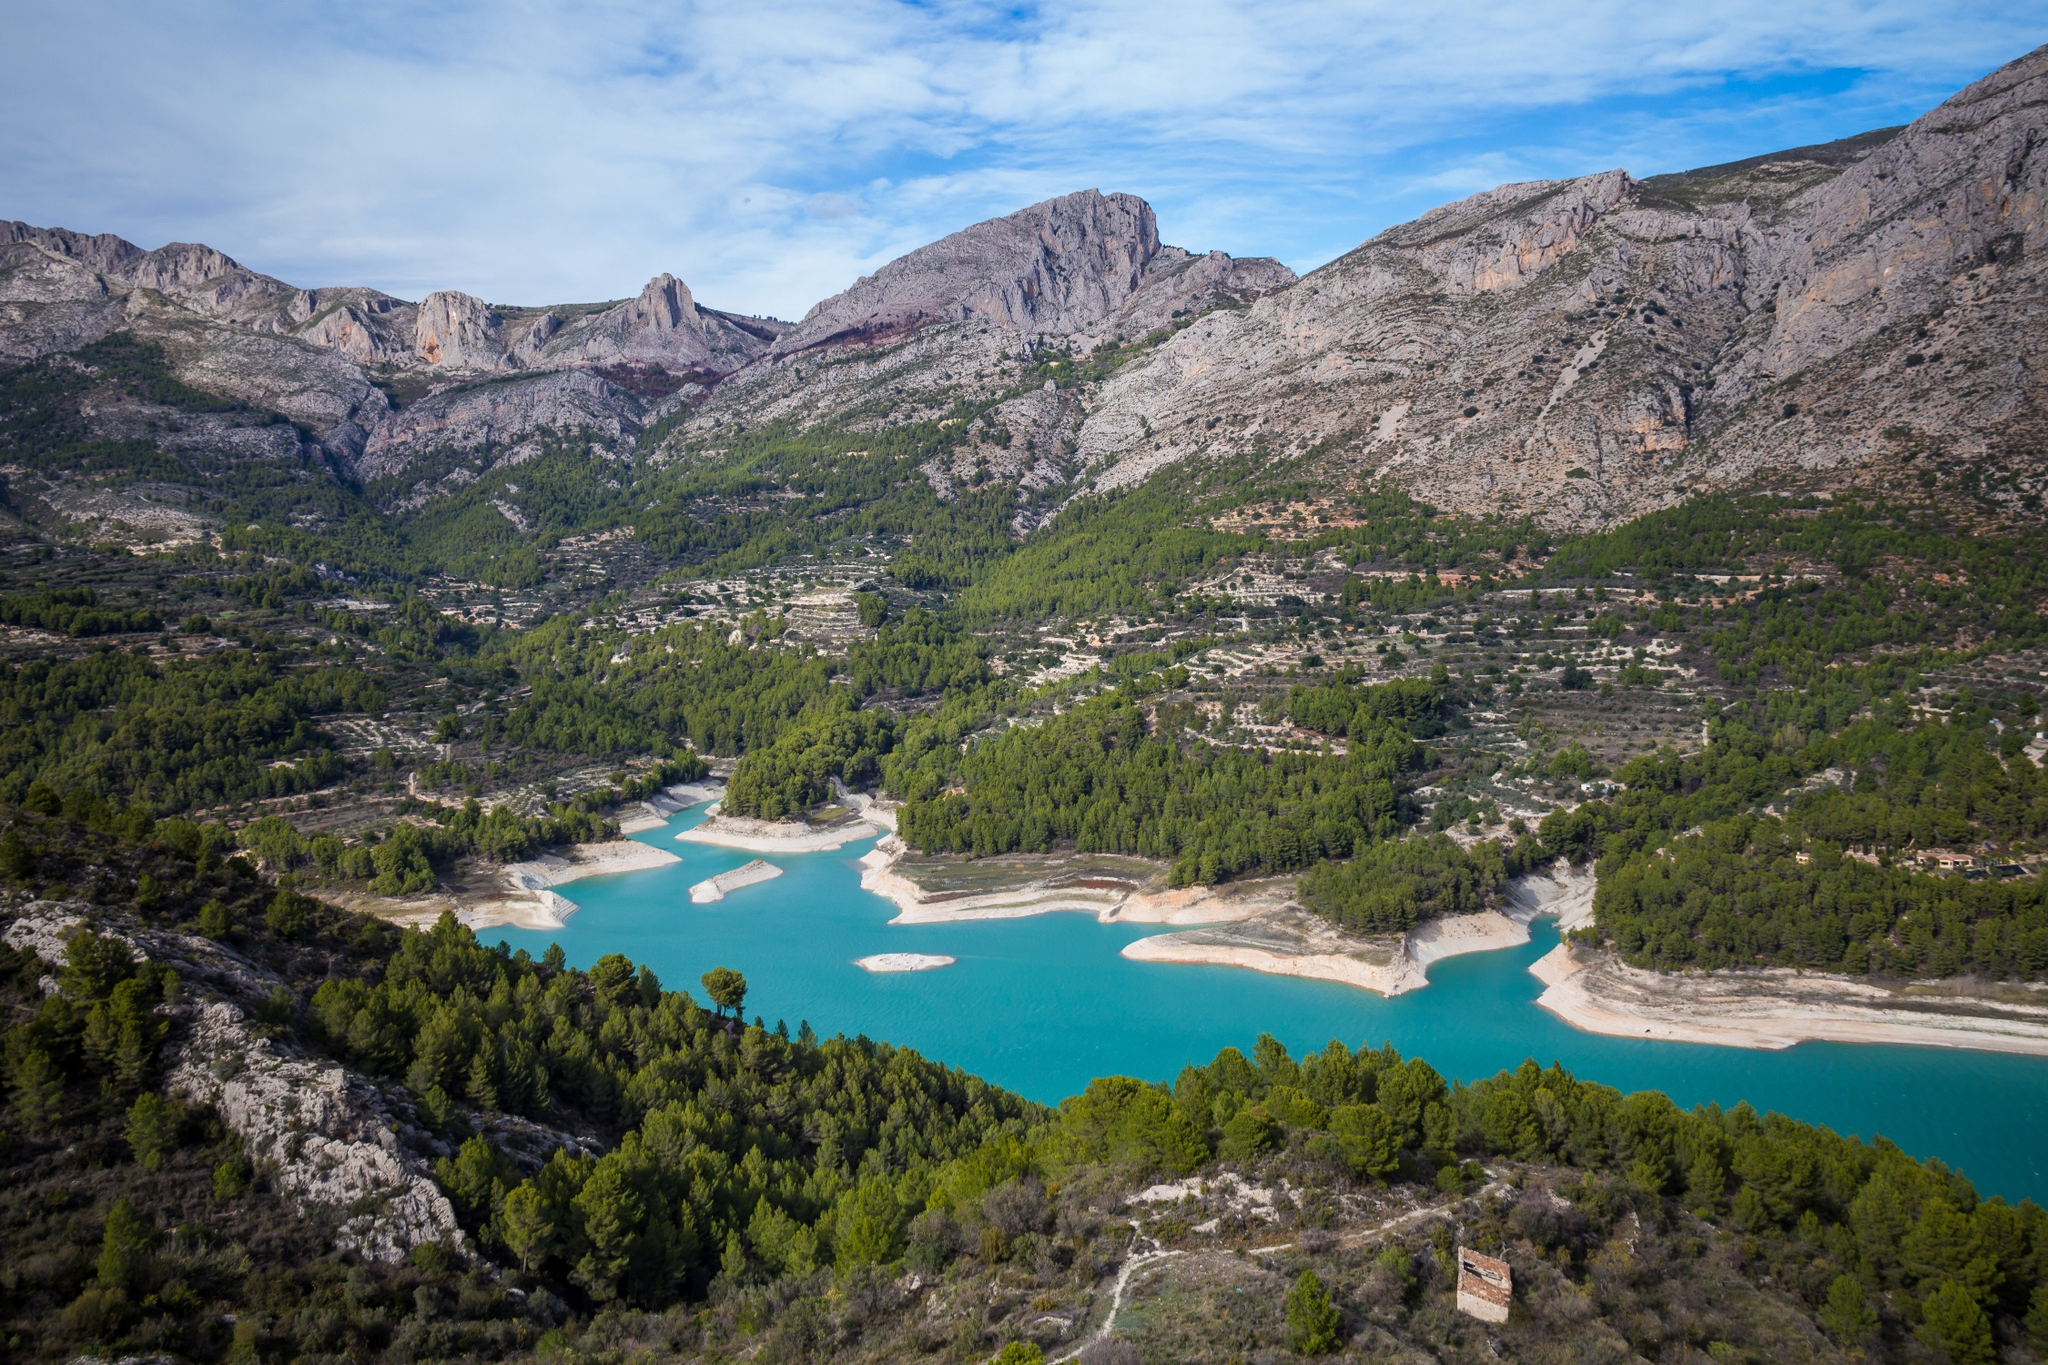Can you elaborate on the elements of the picture provided? The image presents a stunning aerial view of the Guadalest Reservoir, located in Alicante, Spain. The reservoir is distinguished by its vibrant turquoise waters, which strikingly contrast with the lush greenery of the surrounding landscape. Enclosed by a variety of trees and dense vegetation, the reservoir acts as a visual centerpiece. Beyond the immediate vicinity, the rugged mountains, predominantly in shades of gray with patches of reddish-brown, provide a dramatic background under the clear, blue sky scattered with wispy clouds. This type of environment suggests a rich biodiversity and a natural area favorable for outdoor activities like hiking and photography. 